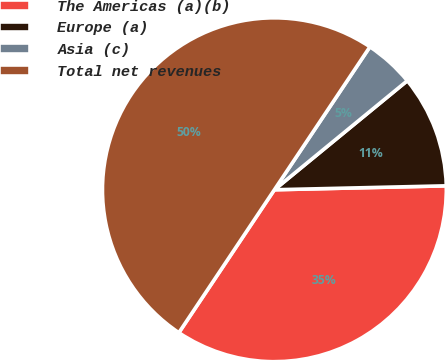Convert chart. <chart><loc_0><loc_0><loc_500><loc_500><pie_chart><fcel>The Americas (a)(b)<fcel>Europe (a)<fcel>Asia (c)<fcel>Total net revenues<nl><fcel>34.74%<fcel>10.57%<fcel>4.69%<fcel>50.0%<nl></chart> 